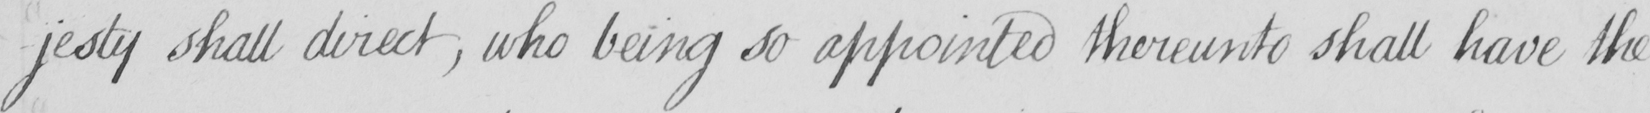Can you tell me what this handwritten text says? -jesty shall direct , who being so appointed thereunto shall have the 